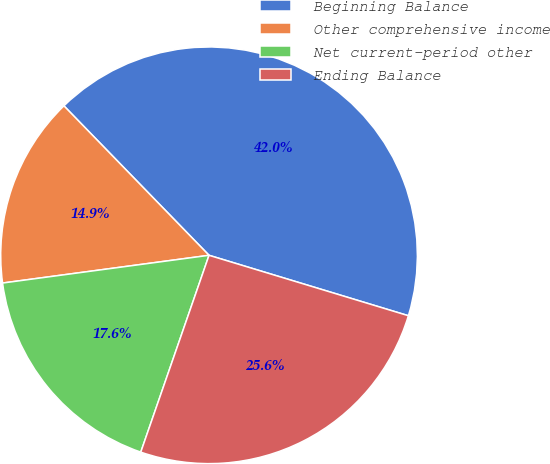Convert chart. <chart><loc_0><loc_0><loc_500><loc_500><pie_chart><fcel>Beginning Balance<fcel>Other comprehensive income<fcel>Net current-period other<fcel>Ending Balance<nl><fcel>41.95%<fcel>14.86%<fcel>17.56%<fcel>25.63%<nl></chart> 